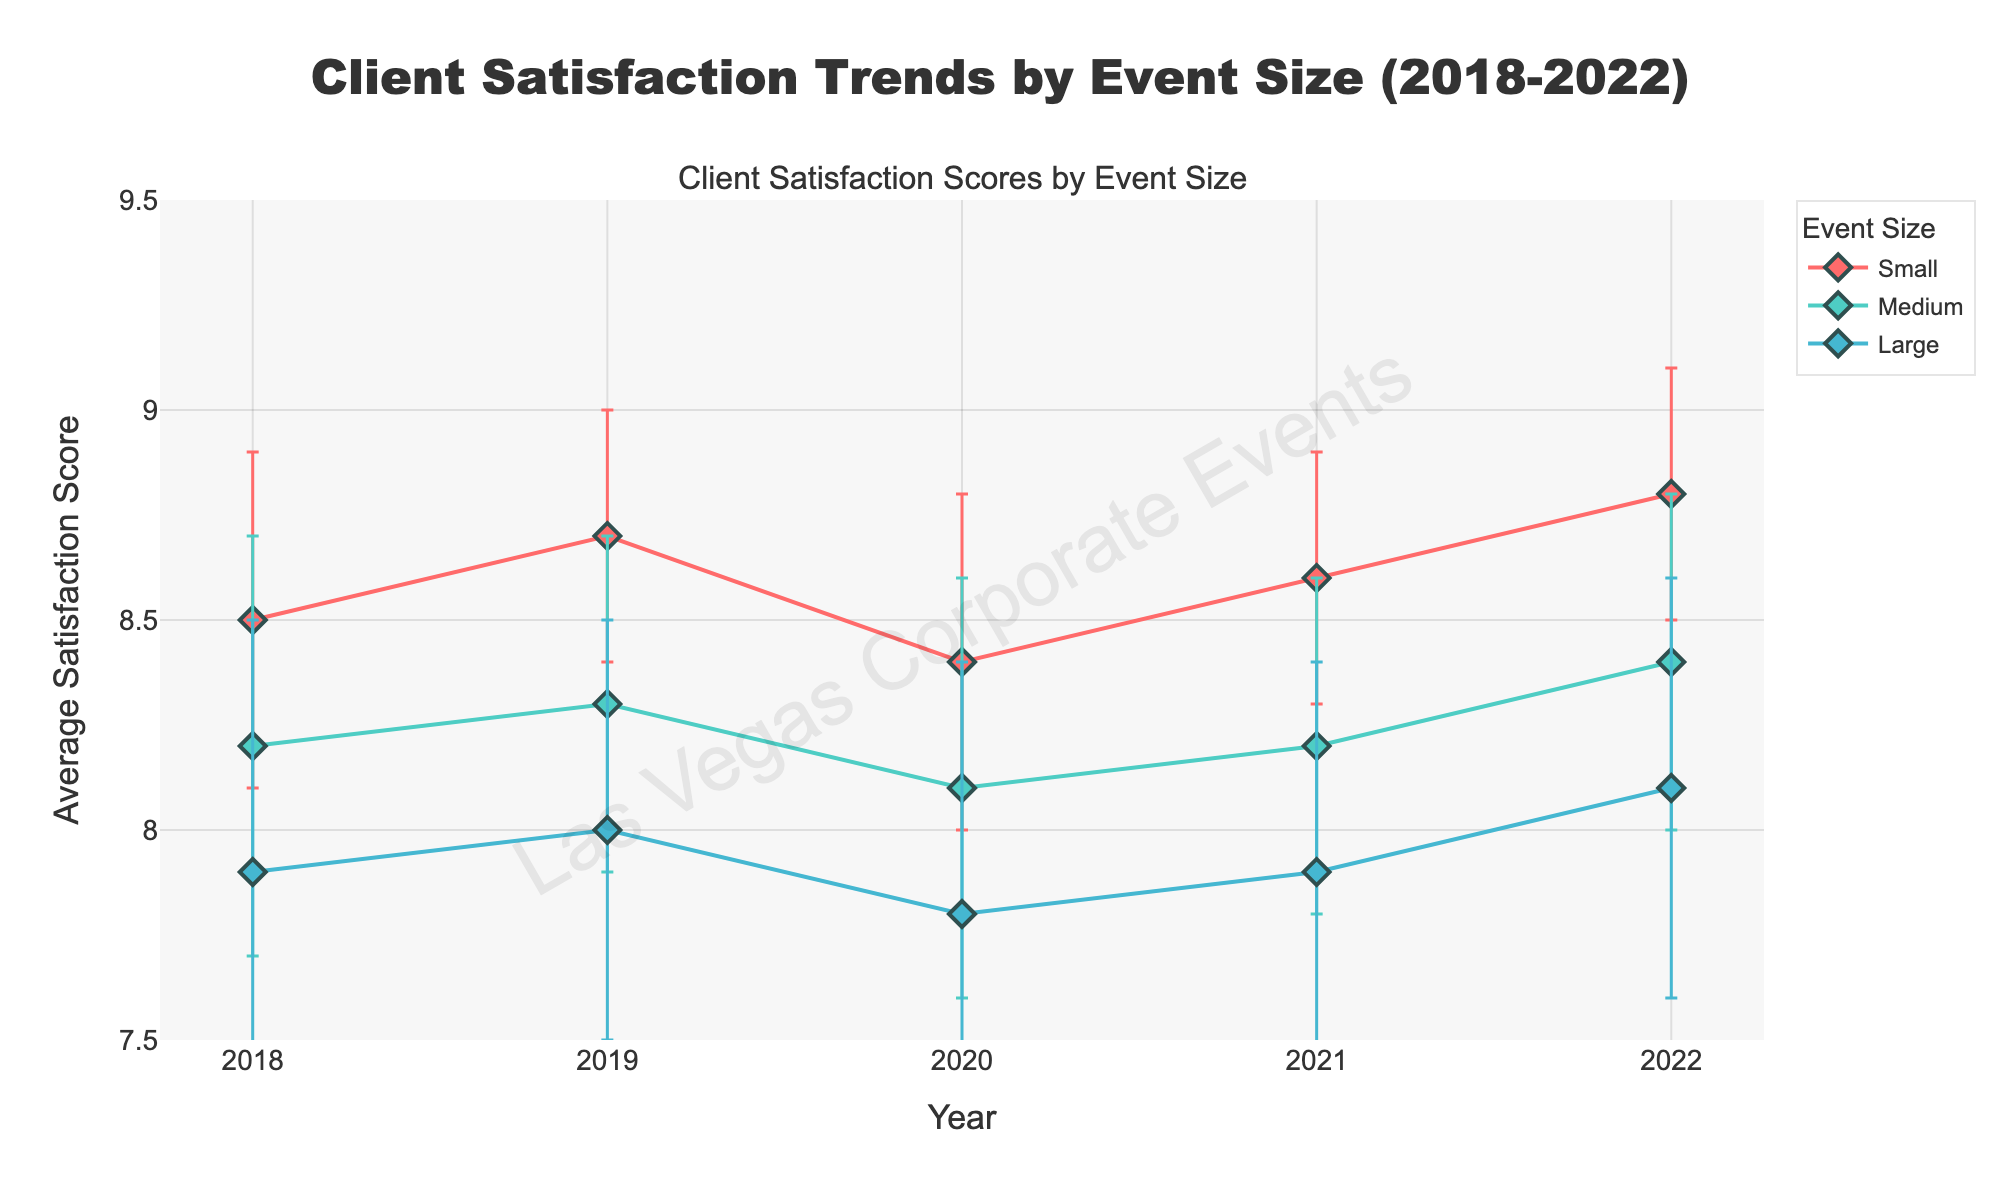What is the highest average satisfaction score for small events? The highest average satisfaction score can be found by looking at the highest point on the line corresponding to small events.
Answer: 8.8 What year had the lowest satisfaction score for large events? To find the lowest satisfaction score for large events, look at the lowest point on the line corresponding to large events.
Answer: 2020 How much did the average satisfaction score for medium events increase from 2018 to 2022? Find the average satisfaction score for medium events in 2018 and 2022 and calculate the difference. 8.4 (2022) - 8.2 (2018) = 0.2.
Answer: 0.2 What are the error margins for the satisfaction score of small events in 2019? The error margin can be observed by looking at the size of the error bars on the plot for small events in the year 2019.
Answer: 0.3 Which year had the same average satisfaction score for both small and medium events? Identify the year where the points for small and medium events are at the same height on the plot.
Answer: None Did the satisfaction score for large events ever exceed 8.1? Check if the line corresponding to large events crosses or reaches above the value of 8.1 on the y-axis.
Answer: No Between 2020 and 2021, did the average satisfaction score for small events increase or decrease? Compare the points for small events in 2020 and 2021 to see if the score went up or down.
Answer: Increase What was the trend in satisfaction scores for large events from 2018 to 2022? Observe the plot for large events from 2018 to 2022. The trend can be seen as whether the line is generally going up, down, or staying level.
Answer: Increasing Which event size had the highest satisfaction score volatility over the years? The volatility is indicated by the size and frequency of error bars. The largest error margins and the most variability in the line plot suggest the highest volatility.
Answer: Large events 